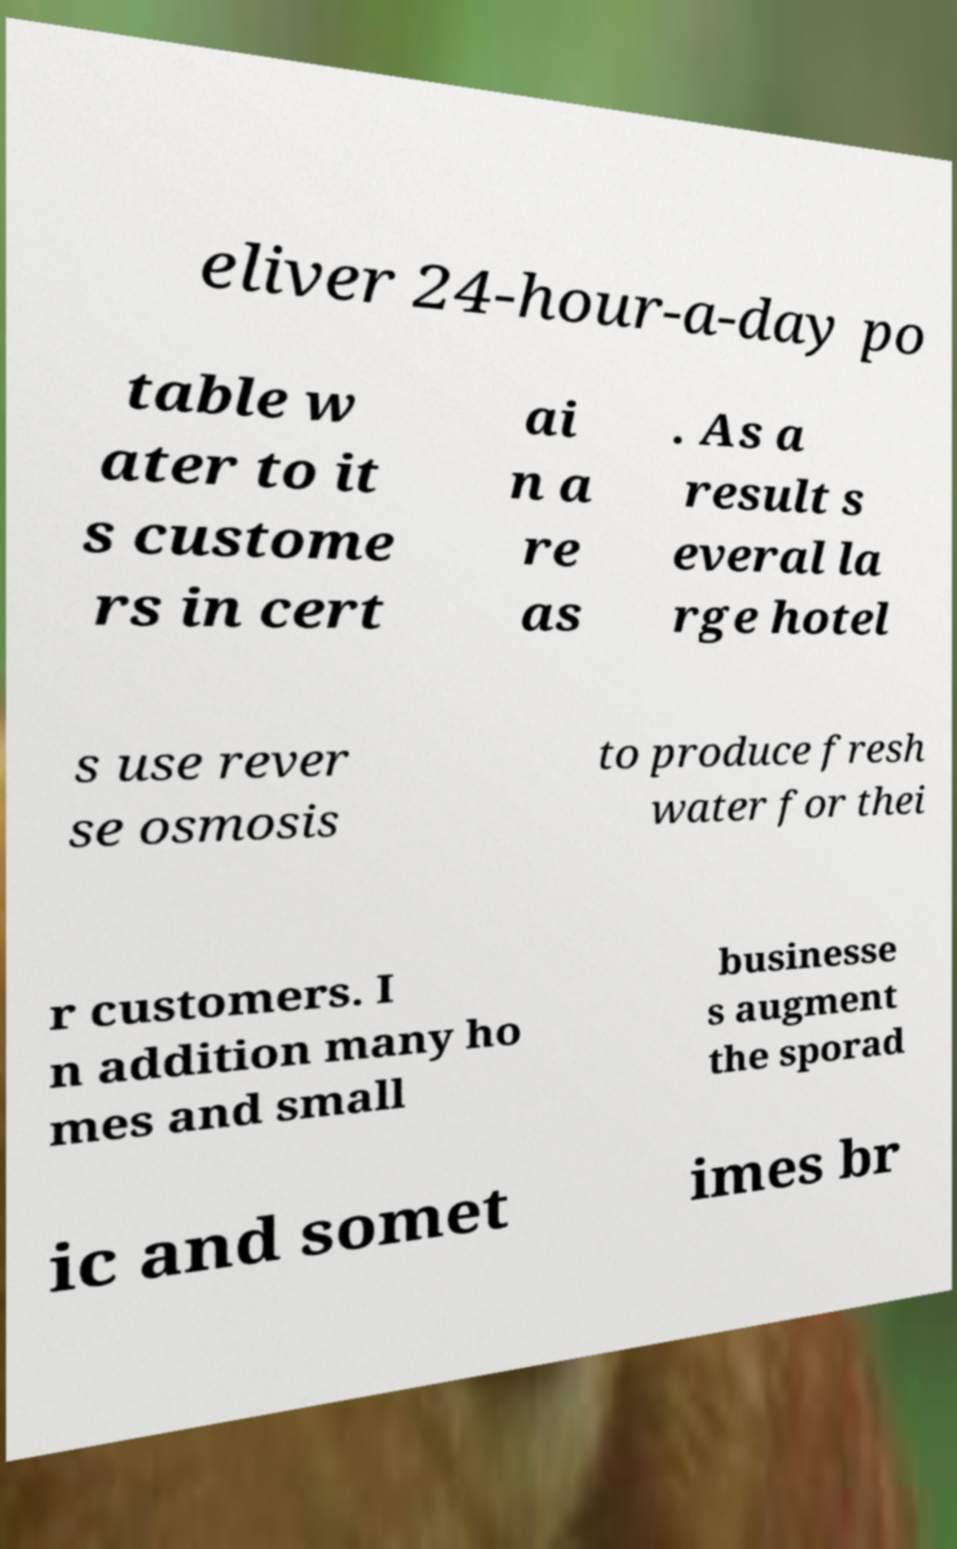Can you accurately transcribe the text from the provided image for me? eliver 24-hour-a-day po table w ater to it s custome rs in cert ai n a re as . As a result s everal la rge hotel s use rever se osmosis to produce fresh water for thei r customers. I n addition many ho mes and small businesse s augment the sporad ic and somet imes br 